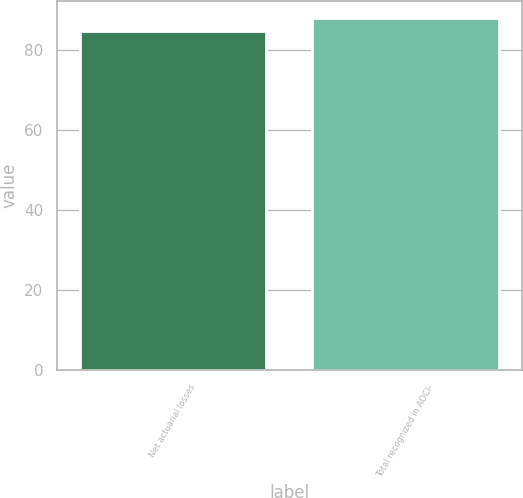Convert chart. <chart><loc_0><loc_0><loc_500><loc_500><bar_chart><fcel>Net actuarial losses<fcel>Total recognized in AOCI-<nl><fcel>84.6<fcel>87.9<nl></chart> 